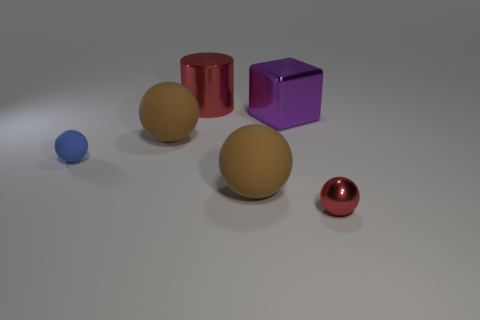What number of cubes are either large red objects or small red things?
Offer a terse response. 0. What number of things are tiny blue matte objects or red objects behind the tiny matte thing?
Your response must be concise. 2. Are any blue matte objects visible?
Give a very brief answer. Yes. What number of other objects have the same color as the small shiny thing?
Keep it short and to the point. 1. There is a brown thing that is right of the red shiny object that is behind the tiny red sphere; what is its size?
Your answer should be compact. Large. Is there a cyan ball that has the same material as the blue sphere?
Provide a short and direct response. No. There is a object that is the same size as the red shiny ball; what material is it?
Your answer should be compact. Rubber. There is a big thing that is behind the big purple metallic cube; does it have the same color as the metallic object that is in front of the purple object?
Offer a very short reply. Yes. There is a tiny ball right of the metallic cylinder; is there a large purple object behind it?
Offer a terse response. Yes. There is a big brown object that is behind the tiny matte ball; does it have the same shape as the big brown object in front of the blue matte ball?
Offer a very short reply. Yes. 